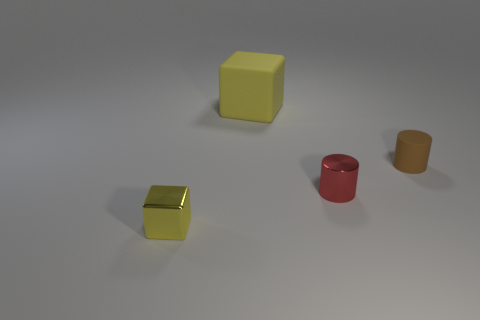Is there any other thing that is the same size as the yellow rubber block?
Provide a short and direct response. No. What is the size of the brown cylinder?
Offer a terse response. Small. What is the material of the yellow block that is behind the yellow block in front of the yellow cube that is behind the metallic cube?
Ensure brevity in your answer.  Rubber. What color is the small thing that is made of the same material as the small red cylinder?
Keep it short and to the point. Yellow. There is a rubber thing in front of the rubber object that is to the left of the small matte object; how many matte cylinders are behind it?
Your response must be concise. 0. There is a block that is the same color as the big thing; what is it made of?
Your response must be concise. Metal. Is there any other thing that has the same shape as the small brown thing?
Ensure brevity in your answer.  Yes. What number of things are either cylinders that are to the right of the small red object or cubes?
Your answer should be very brief. 3. Do the small thing in front of the red cylinder and the matte block have the same color?
Offer a terse response. Yes. There is a object that is right of the tiny cylinder left of the small brown thing; what shape is it?
Your answer should be compact. Cylinder. 